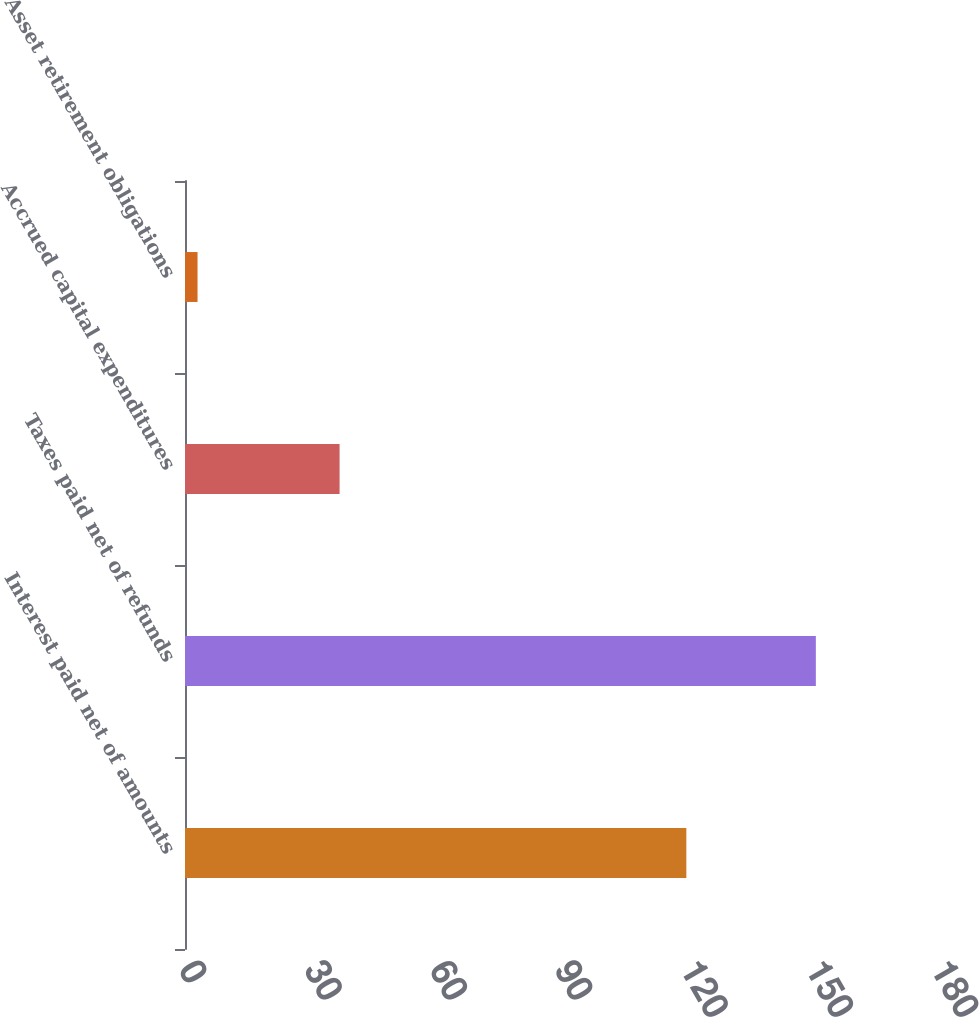Convert chart. <chart><loc_0><loc_0><loc_500><loc_500><bar_chart><fcel>Interest paid net of amounts<fcel>Taxes paid net of refunds<fcel>Accrued capital expenditures<fcel>Asset retirement obligations<nl><fcel>120<fcel>151<fcel>37<fcel>3<nl></chart> 